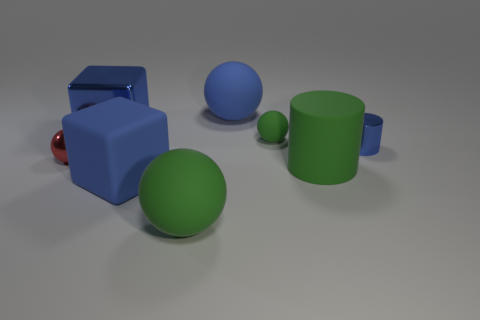Subtract all green balls. How many were subtracted if there are1green balls left? 1 Subtract 1 spheres. How many spheres are left? 3 Add 1 large brown shiny balls. How many objects exist? 9 Subtract all blocks. How many objects are left? 6 Add 2 tiny blue metal objects. How many tiny blue metal objects are left? 3 Add 4 matte objects. How many matte objects exist? 9 Subtract 0 brown cylinders. How many objects are left? 8 Subtract all big gray rubber cylinders. Subtract all tiny blue metal cylinders. How many objects are left? 7 